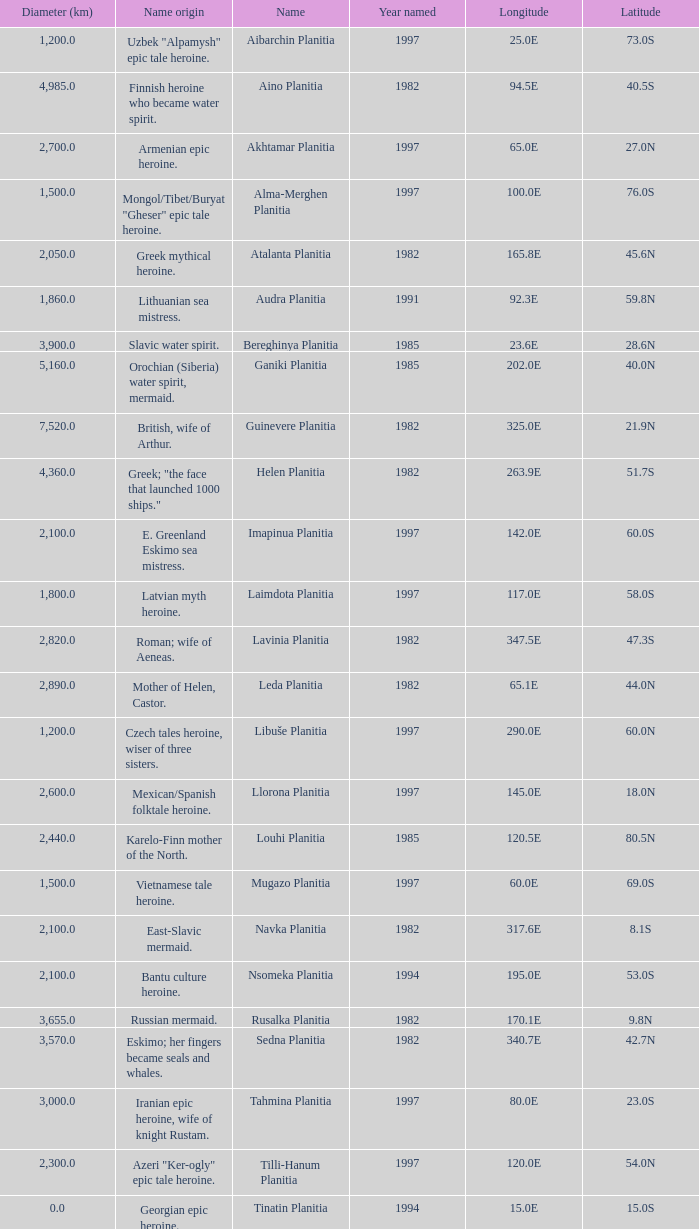What is the latitude of the feature of longitude 80.0e 23.0S. 